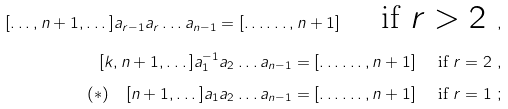Convert formula to latex. <formula><loc_0><loc_0><loc_500><loc_500>[ \dots , n + 1 , \dots ] a _ { r - 1 } a _ { r } \dots a _ { n - 1 } = [ \dots \dots , n + 1 ] \quad \text { if $r>2$ } , \\ [ k , n + 1 , \dots ] a _ { 1 } ^ { - 1 } a _ { 2 } \dots a _ { n - 1 } = [ \dots \dots , n + 1 ] \quad \text { if $r=2$ } , \\ ( * ) \quad [ n + 1 , \dots ] a _ { 1 } a _ { 2 } \dots a _ { n - 1 } = [ \dots \dots , n + 1 ] \quad \text { if $r=1$ } ;</formula> 